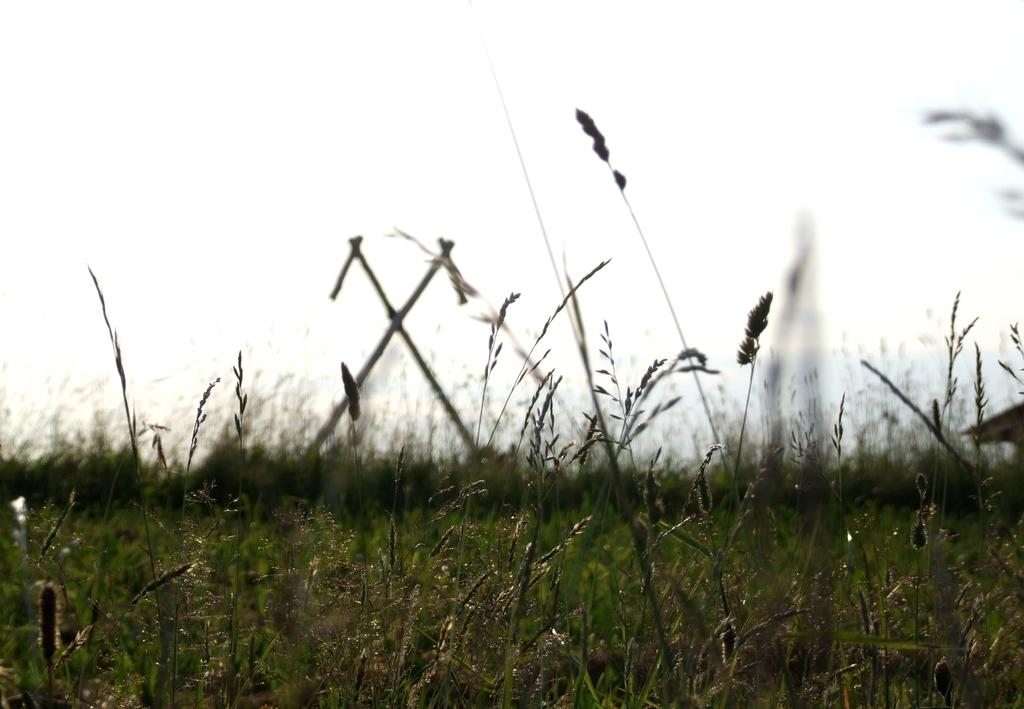What type of plants can be seen in the image? There are plants with seeds in the image. Can you describe the plants in the background of the image? There are plants in the background of the image, but their specific characteristics are not mentioned in the facts. What can be seen in the sky in the background of the image? The sky is visible in the background of the image, but no specific details about the sky are provided in the facts. What type of grape is being traded between nations in the image? There is no mention of grapes or trade in the image, so this question cannot be answered definitively. 